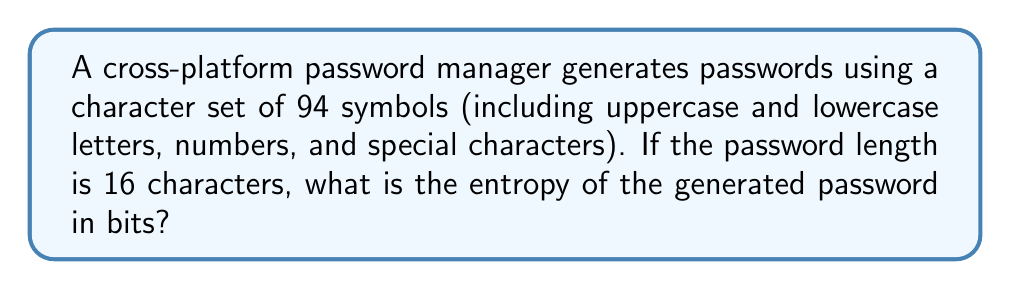Teach me how to tackle this problem. Let's approach this step-by-step:

1) The entropy of a password is calculated using the formula:

   $$E = L * \log_2(R)$$

   Where:
   $E$ is the entropy in bits
   $L$ is the length of the password
   $R$ is the size of the character set

2) We're given:
   $L = 16$ (password length)
   $R = 94$ (size of character set)

3) Plugging these values into the formula:

   $$E = 16 * \log_2(94)$$

4) To calculate $\log_2(94)$, we can use the change of base formula:

   $$\log_2(94) = \frac{\log(94)}{\log(2)}$$

5) Using a calculator or computer:

   $$\log_2(94) \approx 6.554590761475768$$

6) Now we can complete the calculation:

   $$E = 16 * 6.554590761475768 \approx 104.87345218361229$$

7) Rounding to two decimal places:

   $$E \approx 104.87 \text{ bits}$$

This high entropy demonstrates the strength of passwords generated by cross-platform password managers, highlighting the security benefits of using such tools for mobile development across different platforms.
Answer: 104.87 bits 